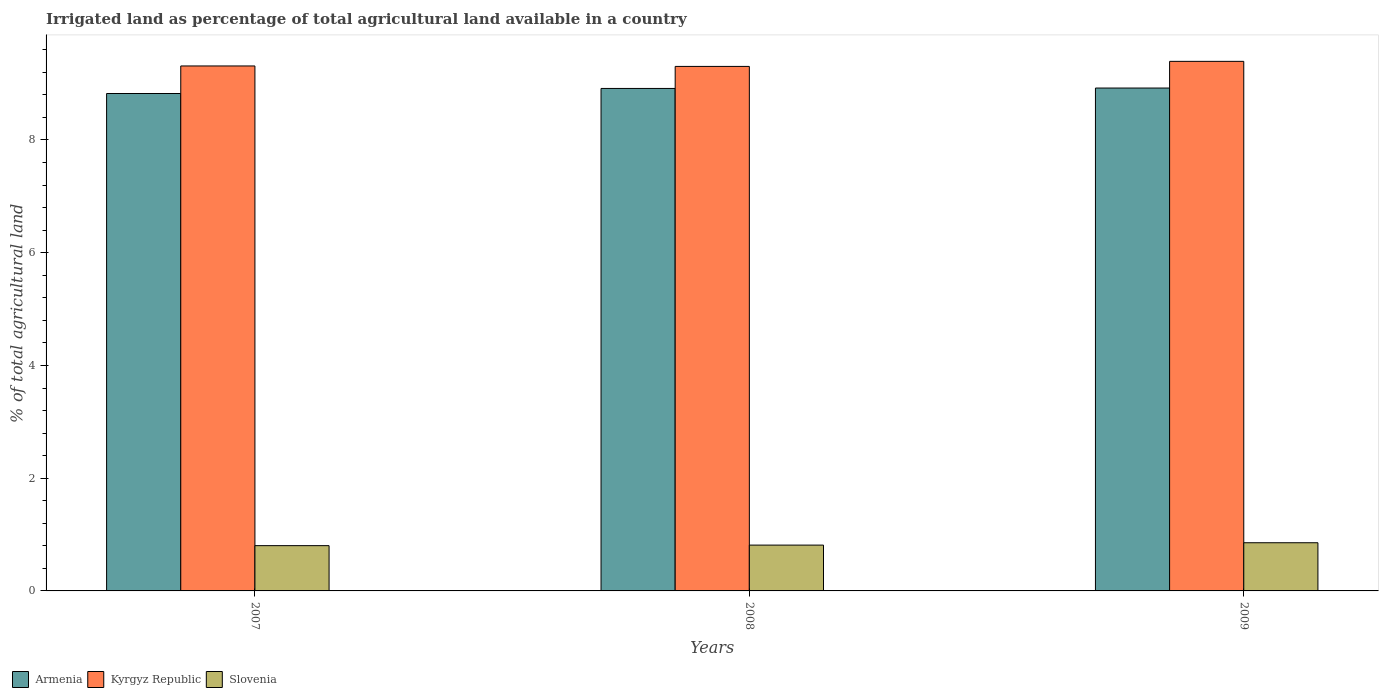How many different coloured bars are there?
Provide a succinct answer. 3. How many bars are there on the 2nd tick from the left?
Provide a short and direct response. 3. How many bars are there on the 3rd tick from the right?
Your response must be concise. 3. What is the label of the 2nd group of bars from the left?
Ensure brevity in your answer.  2008. What is the percentage of irrigated land in Armenia in 2009?
Make the answer very short. 8.92. Across all years, what is the maximum percentage of irrigated land in Armenia?
Provide a short and direct response. 8.92. Across all years, what is the minimum percentage of irrigated land in Slovenia?
Provide a short and direct response. 0.8. What is the total percentage of irrigated land in Kyrgyz Republic in the graph?
Make the answer very short. 28.01. What is the difference between the percentage of irrigated land in Kyrgyz Republic in 2007 and that in 2009?
Ensure brevity in your answer.  -0.08. What is the difference between the percentage of irrigated land in Kyrgyz Republic in 2007 and the percentage of irrigated land in Slovenia in 2009?
Provide a short and direct response. 8.46. What is the average percentage of irrigated land in Slovenia per year?
Ensure brevity in your answer.  0.82. In the year 2008, what is the difference between the percentage of irrigated land in Armenia and percentage of irrigated land in Slovenia?
Provide a succinct answer. 8.1. What is the ratio of the percentage of irrigated land in Armenia in 2007 to that in 2009?
Provide a succinct answer. 0.99. Is the percentage of irrigated land in Kyrgyz Republic in 2007 less than that in 2008?
Offer a terse response. No. Is the difference between the percentage of irrigated land in Armenia in 2007 and 2008 greater than the difference between the percentage of irrigated land in Slovenia in 2007 and 2008?
Offer a terse response. No. What is the difference between the highest and the second highest percentage of irrigated land in Slovenia?
Make the answer very short. 0.04. What is the difference between the highest and the lowest percentage of irrigated land in Slovenia?
Provide a short and direct response. 0.05. What does the 2nd bar from the left in 2009 represents?
Give a very brief answer. Kyrgyz Republic. What does the 1st bar from the right in 2007 represents?
Provide a succinct answer. Slovenia. Is it the case that in every year, the sum of the percentage of irrigated land in Kyrgyz Republic and percentage of irrigated land in Armenia is greater than the percentage of irrigated land in Slovenia?
Give a very brief answer. Yes. How many bars are there?
Your answer should be very brief. 9. Are all the bars in the graph horizontal?
Your answer should be very brief. No. What is the difference between two consecutive major ticks on the Y-axis?
Offer a terse response. 2. Where does the legend appear in the graph?
Ensure brevity in your answer.  Bottom left. How are the legend labels stacked?
Your response must be concise. Horizontal. What is the title of the graph?
Your response must be concise. Irrigated land as percentage of total agricultural land available in a country. Does "Honduras" appear as one of the legend labels in the graph?
Provide a short and direct response. No. What is the label or title of the X-axis?
Give a very brief answer. Years. What is the label or title of the Y-axis?
Give a very brief answer. % of total agricultural land. What is the % of total agricultural land in Armenia in 2007?
Offer a terse response. 8.82. What is the % of total agricultural land in Kyrgyz Republic in 2007?
Provide a succinct answer. 9.31. What is the % of total agricultural land of Slovenia in 2007?
Ensure brevity in your answer.  0.8. What is the % of total agricultural land in Armenia in 2008?
Give a very brief answer. 8.91. What is the % of total agricultural land in Kyrgyz Republic in 2008?
Give a very brief answer. 9.31. What is the % of total agricultural land of Slovenia in 2008?
Your answer should be compact. 0.81. What is the % of total agricultural land of Armenia in 2009?
Provide a succinct answer. 8.92. What is the % of total agricultural land of Kyrgyz Republic in 2009?
Give a very brief answer. 9.4. What is the % of total agricultural land in Slovenia in 2009?
Keep it short and to the point. 0.85. Across all years, what is the maximum % of total agricultural land in Armenia?
Offer a very short reply. 8.92. Across all years, what is the maximum % of total agricultural land of Kyrgyz Republic?
Your answer should be very brief. 9.4. Across all years, what is the maximum % of total agricultural land in Slovenia?
Your answer should be compact. 0.85. Across all years, what is the minimum % of total agricultural land of Armenia?
Provide a succinct answer. 8.82. Across all years, what is the minimum % of total agricultural land in Kyrgyz Republic?
Your answer should be very brief. 9.31. Across all years, what is the minimum % of total agricultural land in Slovenia?
Your answer should be compact. 0.8. What is the total % of total agricultural land in Armenia in the graph?
Provide a succinct answer. 26.66. What is the total % of total agricultural land in Kyrgyz Republic in the graph?
Make the answer very short. 28.01. What is the total % of total agricultural land in Slovenia in the graph?
Keep it short and to the point. 2.47. What is the difference between the % of total agricultural land of Armenia in 2007 and that in 2008?
Your response must be concise. -0.09. What is the difference between the % of total agricultural land in Kyrgyz Republic in 2007 and that in 2008?
Ensure brevity in your answer.  0.01. What is the difference between the % of total agricultural land of Slovenia in 2007 and that in 2008?
Ensure brevity in your answer.  -0.01. What is the difference between the % of total agricultural land in Armenia in 2007 and that in 2009?
Make the answer very short. -0.1. What is the difference between the % of total agricultural land in Kyrgyz Republic in 2007 and that in 2009?
Your answer should be compact. -0.08. What is the difference between the % of total agricultural land in Slovenia in 2007 and that in 2009?
Make the answer very short. -0.05. What is the difference between the % of total agricultural land of Armenia in 2008 and that in 2009?
Give a very brief answer. -0.01. What is the difference between the % of total agricultural land of Kyrgyz Republic in 2008 and that in 2009?
Your answer should be very brief. -0.09. What is the difference between the % of total agricultural land of Slovenia in 2008 and that in 2009?
Provide a succinct answer. -0.04. What is the difference between the % of total agricultural land of Armenia in 2007 and the % of total agricultural land of Kyrgyz Republic in 2008?
Provide a short and direct response. -0.48. What is the difference between the % of total agricultural land of Armenia in 2007 and the % of total agricultural land of Slovenia in 2008?
Provide a succinct answer. 8.01. What is the difference between the % of total agricultural land in Kyrgyz Republic in 2007 and the % of total agricultural land in Slovenia in 2008?
Make the answer very short. 8.5. What is the difference between the % of total agricultural land of Armenia in 2007 and the % of total agricultural land of Kyrgyz Republic in 2009?
Keep it short and to the point. -0.57. What is the difference between the % of total agricultural land of Armenia in 2007 and the % of total agricultural land of Slovenia in 2009?
Your response must be concise. 7.97. What is the difference between the % of total agricultural land of Kyrgyz Republic in 2007 and the % of total agricultural land of Slovenia in 2009?
Provide a succinct answer. 8.46. What is the difference between the % of total agricultural land of Armenia in 2008 and the % of total agricultural land of Kyrgyz Republic in 2009?
Ensure brevity in your answer.  -0.48. What is the difference between the % of total agricultural land in Armenia in 2008 and the % of total agricultural land in Slovenia in 2009?
Keep it short and to the point. 8.06. What is the difference between the % of total agricultural land in Kyrgyz Republic in 2008 and the % of total agricultural land in Slovenia in 2009?
Ensure brevity in your answer.  8.45. What is the average % of total agricultural land in Armenia per year?
Keep it short and to the point. 8.89. What is the average % of total agricultural land in Kyrgyz Republic per year?
Provide a succinct answer. 9.34. What is the average % of total agricultural land in Slovenia per year?
Offer a terse response. 0.82. In the year 2007, what is the difference between the % of total agricultural land of Armenia and % of total agricultural land of Kyrgyz Republic?
Ensure brevity in your answer.  -0.49. In the year 2007, what is the difference between the % of total agricultural land in Armenia and % of total agricultural land in Slovenia?
Offer a very short reply. 8.02. In the year 2007, what is the difference between the % of total agricultural land of Kyrgyz Republic and % of total agricultural land of Slovenia?
Your answer should be very brief. 8.51. In the year 2008, what is the difference between the % of total agricultural land of Armenia and % of total agricultural land of Kyrgyz Republic?
Offer a terse response. -0.39. In the year 2008, what is the difference between the % of total agricultural land in Armenia and % of total agricultural land in Slovenia?
Your answer should be compact. 8.1. In the year 2008, what is the difference between the % of total agricultural land of Kyrgyz Republic and % of total agricultural land of Slovenia?
Ensure brevity in your answer.  8.49. In the year 2009, what is the difference between the % of total agricultural land of Armenia and % of total agricultural land of Kyrgyz Republic?
Make the answer very short. -0.47. In the year 2009, what is the difference between the % of total agricultural land of Armenia and % of total agricultural land of Slovenia?
Offer a terse response. 8.07. In the year 2009, what is the difference between the % of total agricultural land in Kyrgyz Republic and % of total agricultural land in Slovenia?
Offer a very short reply. 8.54. What is the ratio of the % of total agricultural land in Armenia in 2007 to that in 2008?
Your response must be concise. 0.99. What is the ratio of the % of total agricultural land in Kyrgyz Republic in 2007 to that in 2008?
Your response must be concise. 1. What is the ratio of the % of total agricultural land of Slovenia in 2007 to that in 2008?
Provide a short and direct response. 0.99. What is the ratio of the % of total agricultural land in Armenia in 2007 to that in 2009?
Provide a short and direct response. 0.99. What is the ratio of the % of total agricultural land in Kyrgyz Republic in 2007 to that in 2009?
Your answer should be compact. 0.99. What is the ratio of the % of total agricultural land of Slovenia in 2007 to that in 2009?
Provide a short and direct response. 0.94. What is the ratio of the % of total agricultural land in Armenia in 2008 to that in 2009?
Offer a very short reply. 1. What is the ratio of the % of total agricultural land of Kyrgyz Republic in 2008 to that in 2009?
Make the answer very short. 0.99. What is the ratio of the % of total agricultural land in Slovenia in 2008 to that in 2009?
Provide a succinct answer. 0.95. What is the difference between the highest and the second highest % of total agricultural land of Armenia?
Make the answer very short. 0.01. What is the difference between the highest and the second highest % of total agricultural land in Kyrgyz Republic?
Your answer should be compact. 0.08. What is the difference between the highest and the second highest % of total agricultural land in Slovenia?
Ensure brevity in your answer.  0.04. What is the difference between the highest and the lowest % of total agricultural land in Armenia?
Provide a succinct answer. 0.1. What is the difference between the highest and the lowest % of total agricultural land of Kyrgyz Republic?
Provide a succinct answer. 0.09. What is the difference between the highest and the lowest % of total agricultural land in Slovenia?
Ensure brevity in your answer.  0.05. 